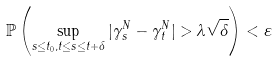Convert formula to latex. <formula><loc_0><loc_0><loc_500><loc_500>\mathbb { P } \left ( \sup _ { s \leq t _ { 0 } , t \leq s \leq t + \delta } | \gamma ^ { N } _ { s } - \gamma ^ { N } _ { t } | > \lambda \sqrt { \delta } \right ) < \varepsilon</formula> 